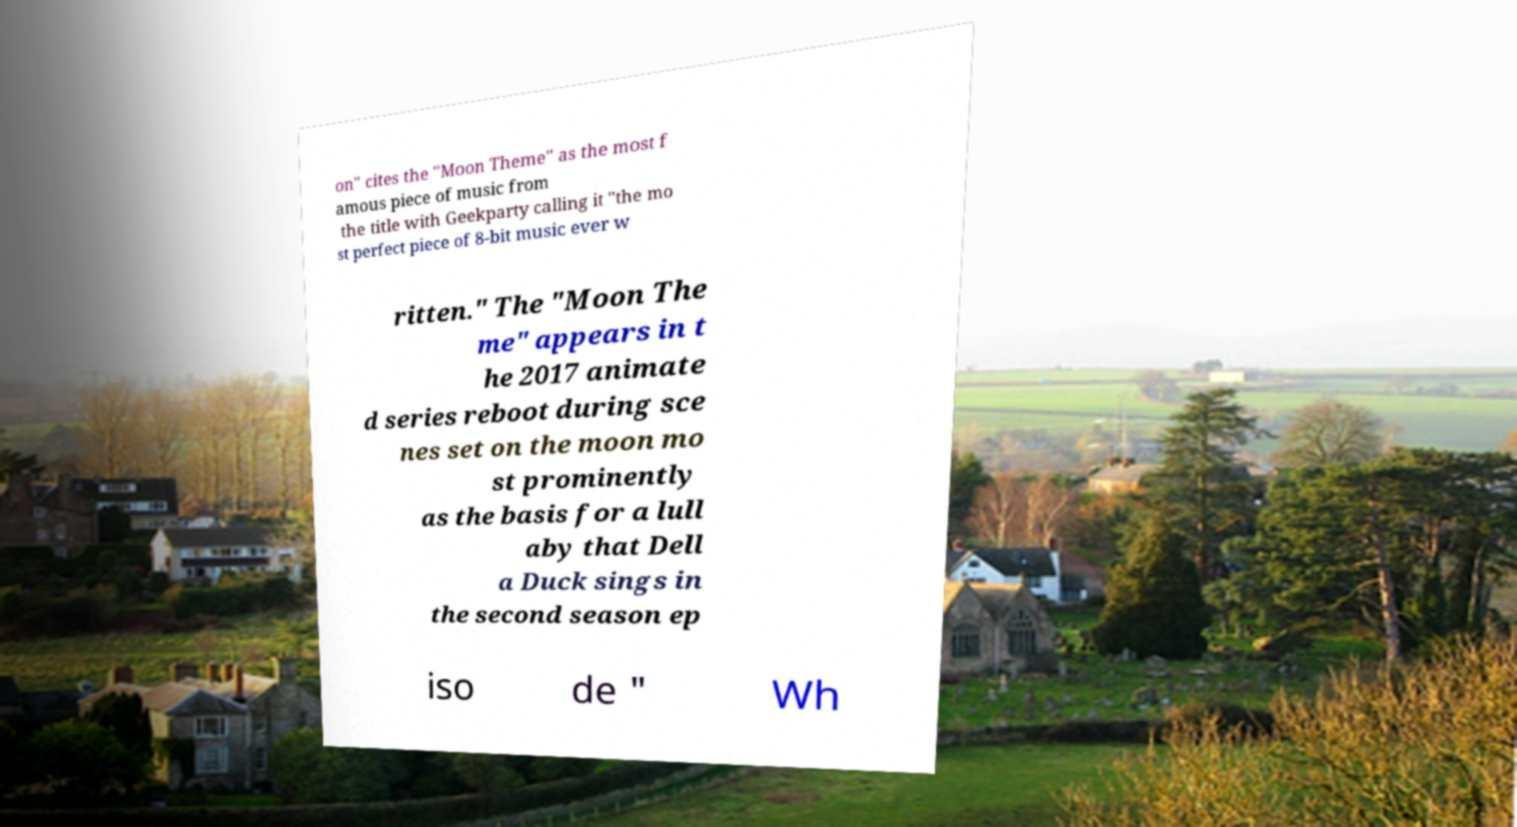Could you assist in decoding the text presented in this image and type it out clearly? on" cites the "Moon Theme" as the most f amous piece of music from the title with Geekparty calling it "the mo st perfect piece of 8-bit music ever w ritten." The "Moon The me" appears in t he 2017 animate d series reboot during sce nes set on the moon mo st prominently as the basis for a lull aby that Dell a Duck sings in the second season ep iso de " Wh 